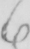Please provide the text content of this handwritten line. 6 . 